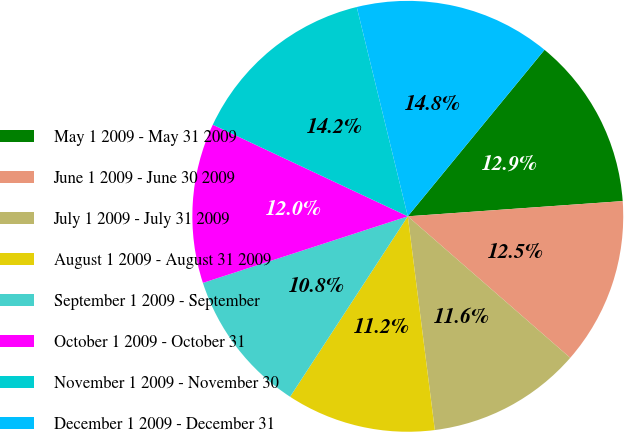Convert chart. <chart><loc_0><loc_0><loc_500><loc_500><pie_chart><fcel>May 1 2009 - May 31 2009<fcel>June 1 2009 - June 30 2009<fcel>July 1 2009 - July 31 2009<fcel>August 1 2009 - August 31 2009<fcel>September 1 2009 - September<fcel>October 1 2009 - October 31<fcel>November 1 2009 - November 30<fcel>December 1 2009 - December 31<nl><fcel>12.93%<fcel>12.53%<fcel>11.59%<fcel>11.2%<fcel>10.8%<fcel>11.99%<fcel>14.2%<fcel>14.75%<nl></chart> 